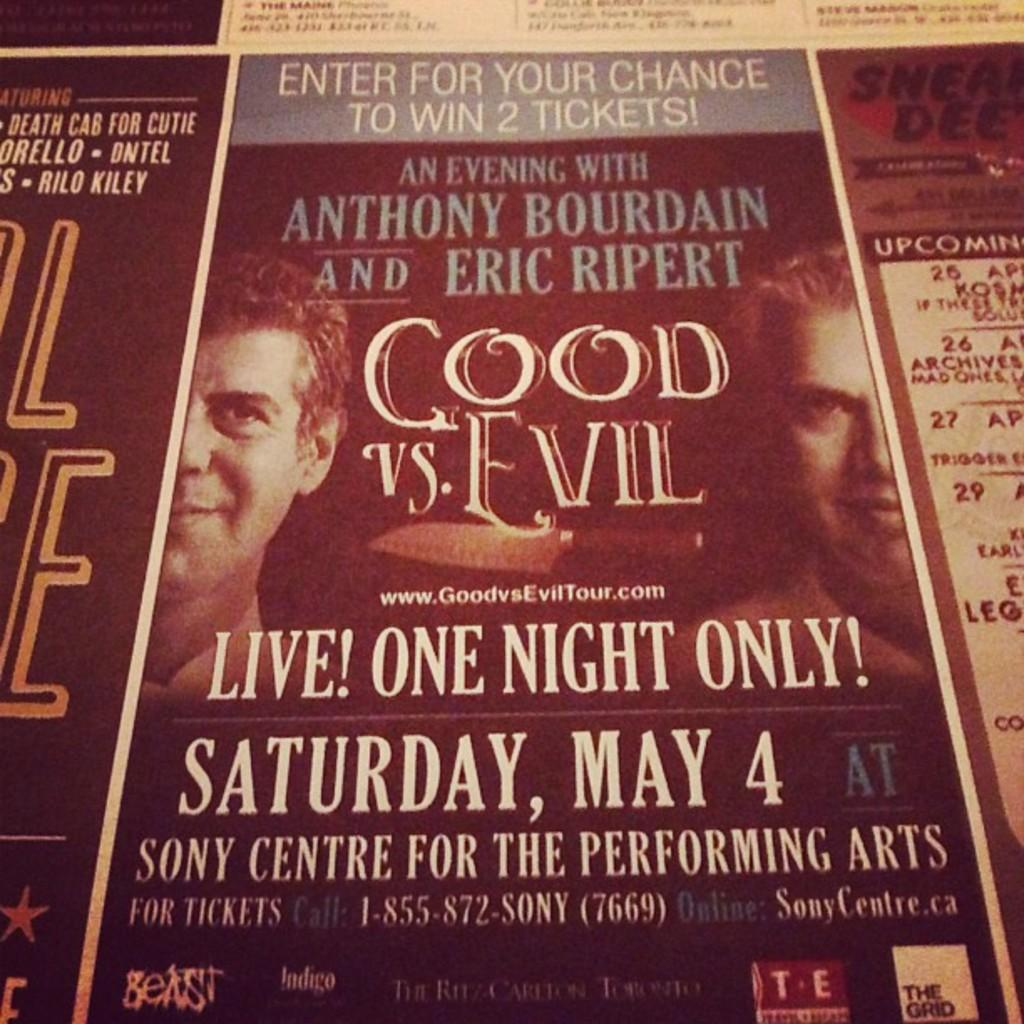<image>
Render a clear and concise summary of the photo. An ad to win tickets to a show called Good vs. Evil. 